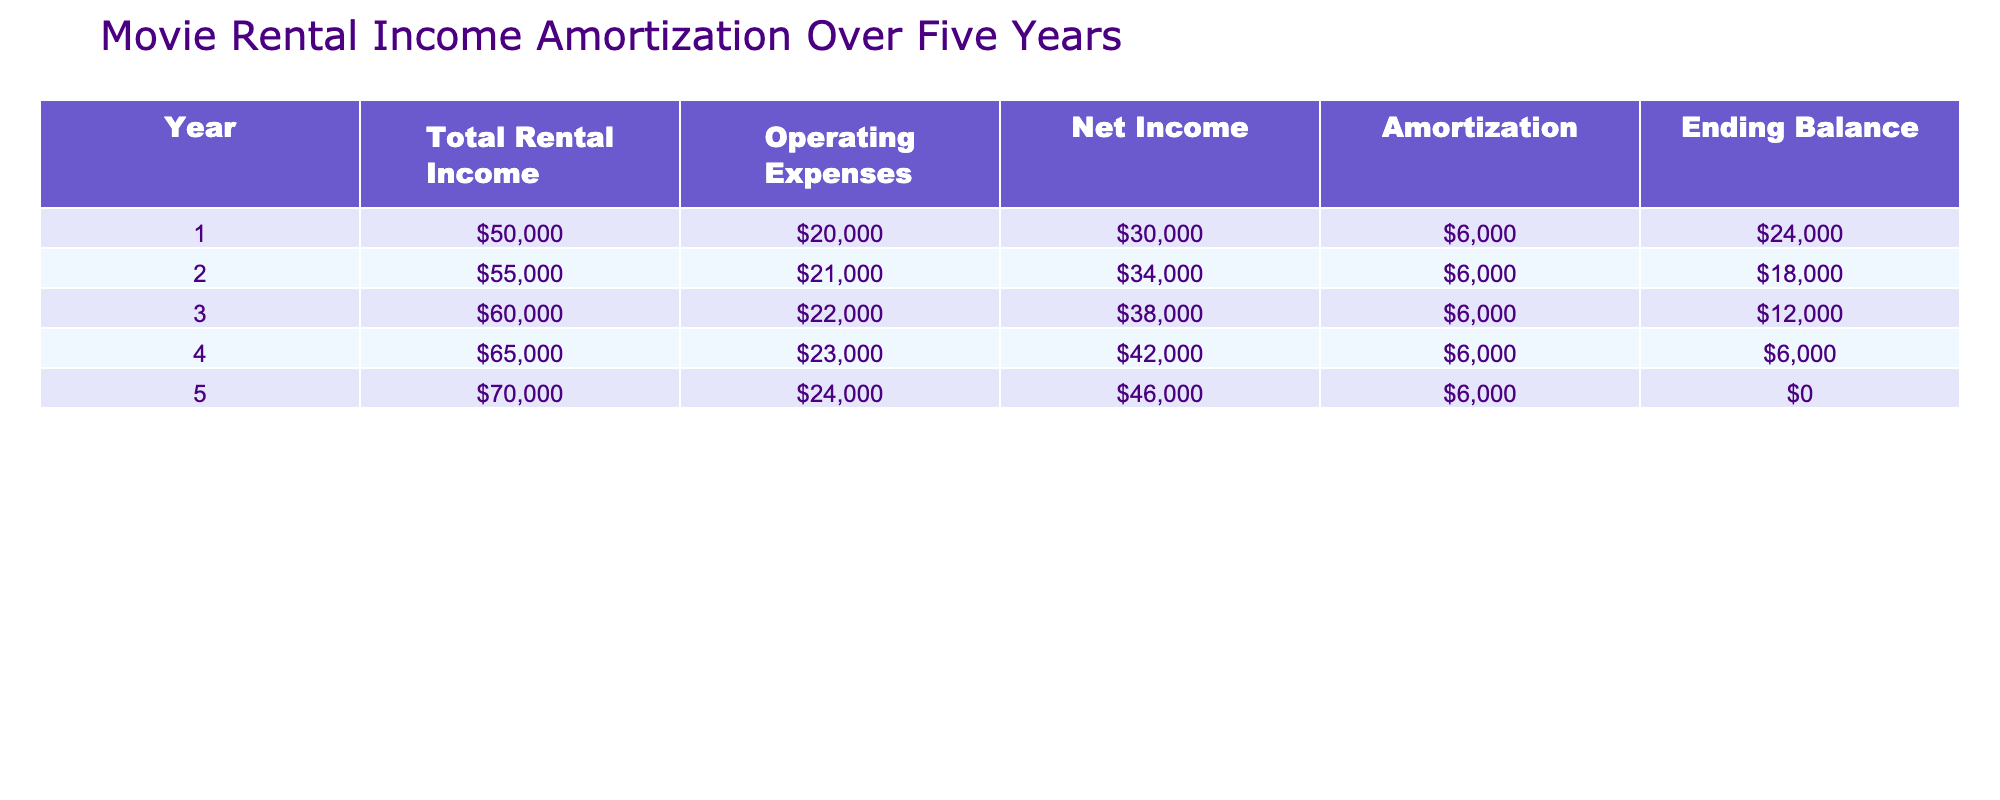What is the total rental income in Year 3? The value for Total Rental Income in Year 3 is listed directly in the table as 60000.
Answer: 60000 What are the operating expenses in Year 4? By looking at the table, the Operating Expenses for Year 4 are clearly mentioned as 23000.
Answer: 23000 What is the net income in Year 5 and how does it compare to Year 1? The Net Income in Year 5 is 46000 and in Year 1 it is 30000. The difference is 46000 - 30000 = 16000, meaning Year 5 has 16000 more net income than Year 1.
Answer: 46000 What is the average amortization amount over the five years? The amortization amounts for the five years are all 6000. To find the average, you sum all amounts (6000*5 = 30000) and then divide by 5, which results in 30000/5 = 6000.
Answer: 6000 In which year did the ending balance reach zero? The Ending Balance reached zero in Year 5, as shown in the table where the value is explicitly stated as 0.
Answer: Year 5 Is the net income in Year 2 greater than the net income in Year 4? The Net Income for Year 2 is 34000, while for Year 4 it is 42000. Since 34000 is less than 42000, the statement is false.
Answer: No What is the cumulative net income over the five years? To find cumulative net income, we sum the Net Income for each year: 30000 + 34000 + 38000 + 42000 + 46000 = 190000.
Answer: 190000 How much did the operating expenses increase from Year 1 to Year 3? The Operating Expenses in Year 1 were 20000, and in Year 3 they were 22000. The increase is 22000 - 20000 = 2000.
Answer: 2000 Was there a year where the net income was equal to the amortization? Looking into the table, the Net Income for each year is 30000, 34000, 38000, 42000, and 46000 while the Amortization is constantly 6000. None of the years show that net income equals amortization.
Answer: No 